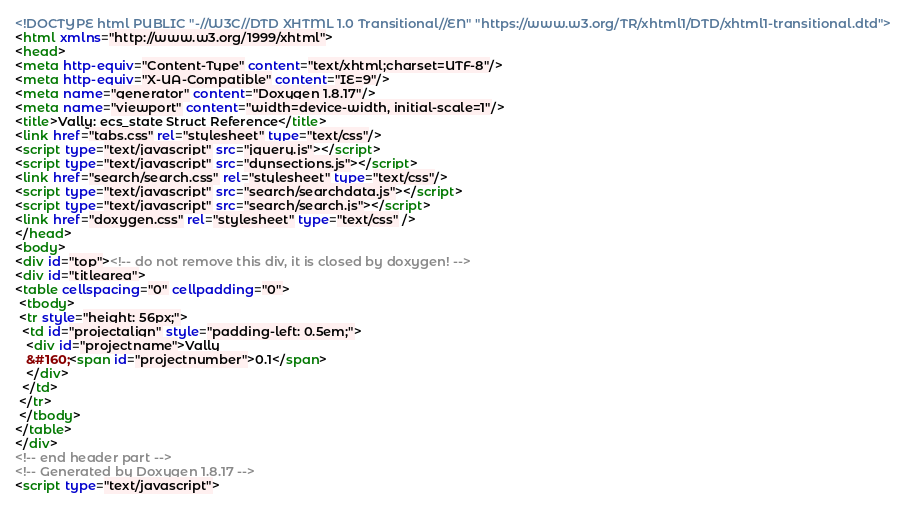<code> <loc_0><loc_0><loc_500><loc_500><_HTML_><!DOCTYPE html PUBLIC "-//W3C//DTD XHTML 1.0 Transitional//EN" "https://www.w3.org/TR/xhtml1/DTD/xhtml1-transitional.dtd">
<html xmlns="http://www.w3.org/1999/xhtml">
<head>
<meta http-equiv="Content-Type" content="text/xhtml;charset=UTF-8"/>
<meta http-equiv="X-UA-Compatible" content="IE=9"/>
<meta name="generator" content="Doxygen 1.8.17"/>
<meta name="viewport" content="width=device-width, initial-scale=1"/>
<title>Vally: ecs_state Struct Reference</title>
<link href="tabs.css" rel="stylesheet" type="text/css"/>
<script type="text/javascript" src="jquery.js"></script>
<script type="text/javascript" src="dynsections.js"></script>
<link href="search/search.css" rel="stylesheet" type="text/css"/>
<script type="text/javascript" src="search/searchdata.js"></script>
<script type="text/javascript" src="search/search.js"></script>
<link href="doxygen.css" rel="stylesheet" type="text/css" />
</head>
<body>
<div id="top"><!-- do not remove this div, it is closed by doxygen! -->
<div id="titlearea">
<table cellspacing="0" cellpadding="0">
 <tbody>
 <tr style="height: 56px;">
  <td id="projectalign" style="padding-left: 0.5em;">
   <div id="projectname">Vally
   &#160;<span id="projectnumber">0.1</span>
   </div>
  </td>
 </tr>
 </tbody>
</table>
</div>
<!-- end header part -->
<!-- Generated by Doxygen 1.8.17 -->
<script type="text/javascript"></code> 